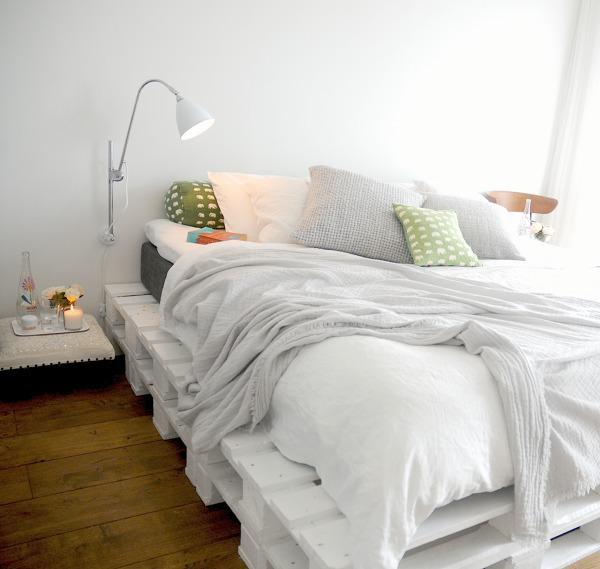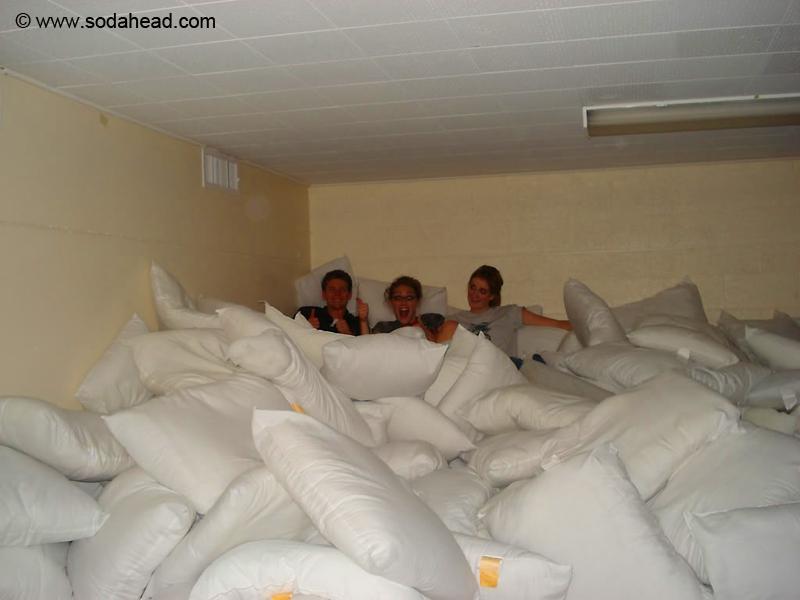The first image is the image on the left, the second image is the image on the right. For the images displayed, is the sentence "There is a lamp visible in at least one image." factually correct? Answer yes or no. Yes. 